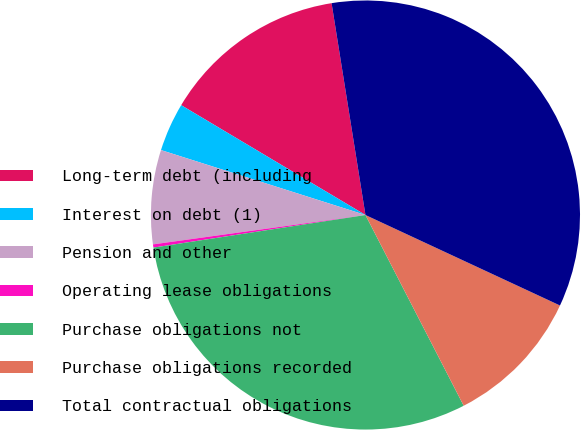<chart> <loc_0><loc_0><loc_500><loc_500><pie_chart><fcel>Long-term debt (including<fcel>Interest on debt (1)<fcel>Pension and other<fcel>Operating lease obligations<fcel>Purchase obligations not<fcel>Purchase obligations recorded<fcel>Total contractual obligations<nl><fcel>13.92%<fcel>3.66%<fcel>7.08%<fcel>0.24%<fcel>30.14%<fcel>10.5%<fcel>34.45%<nl></chart> 